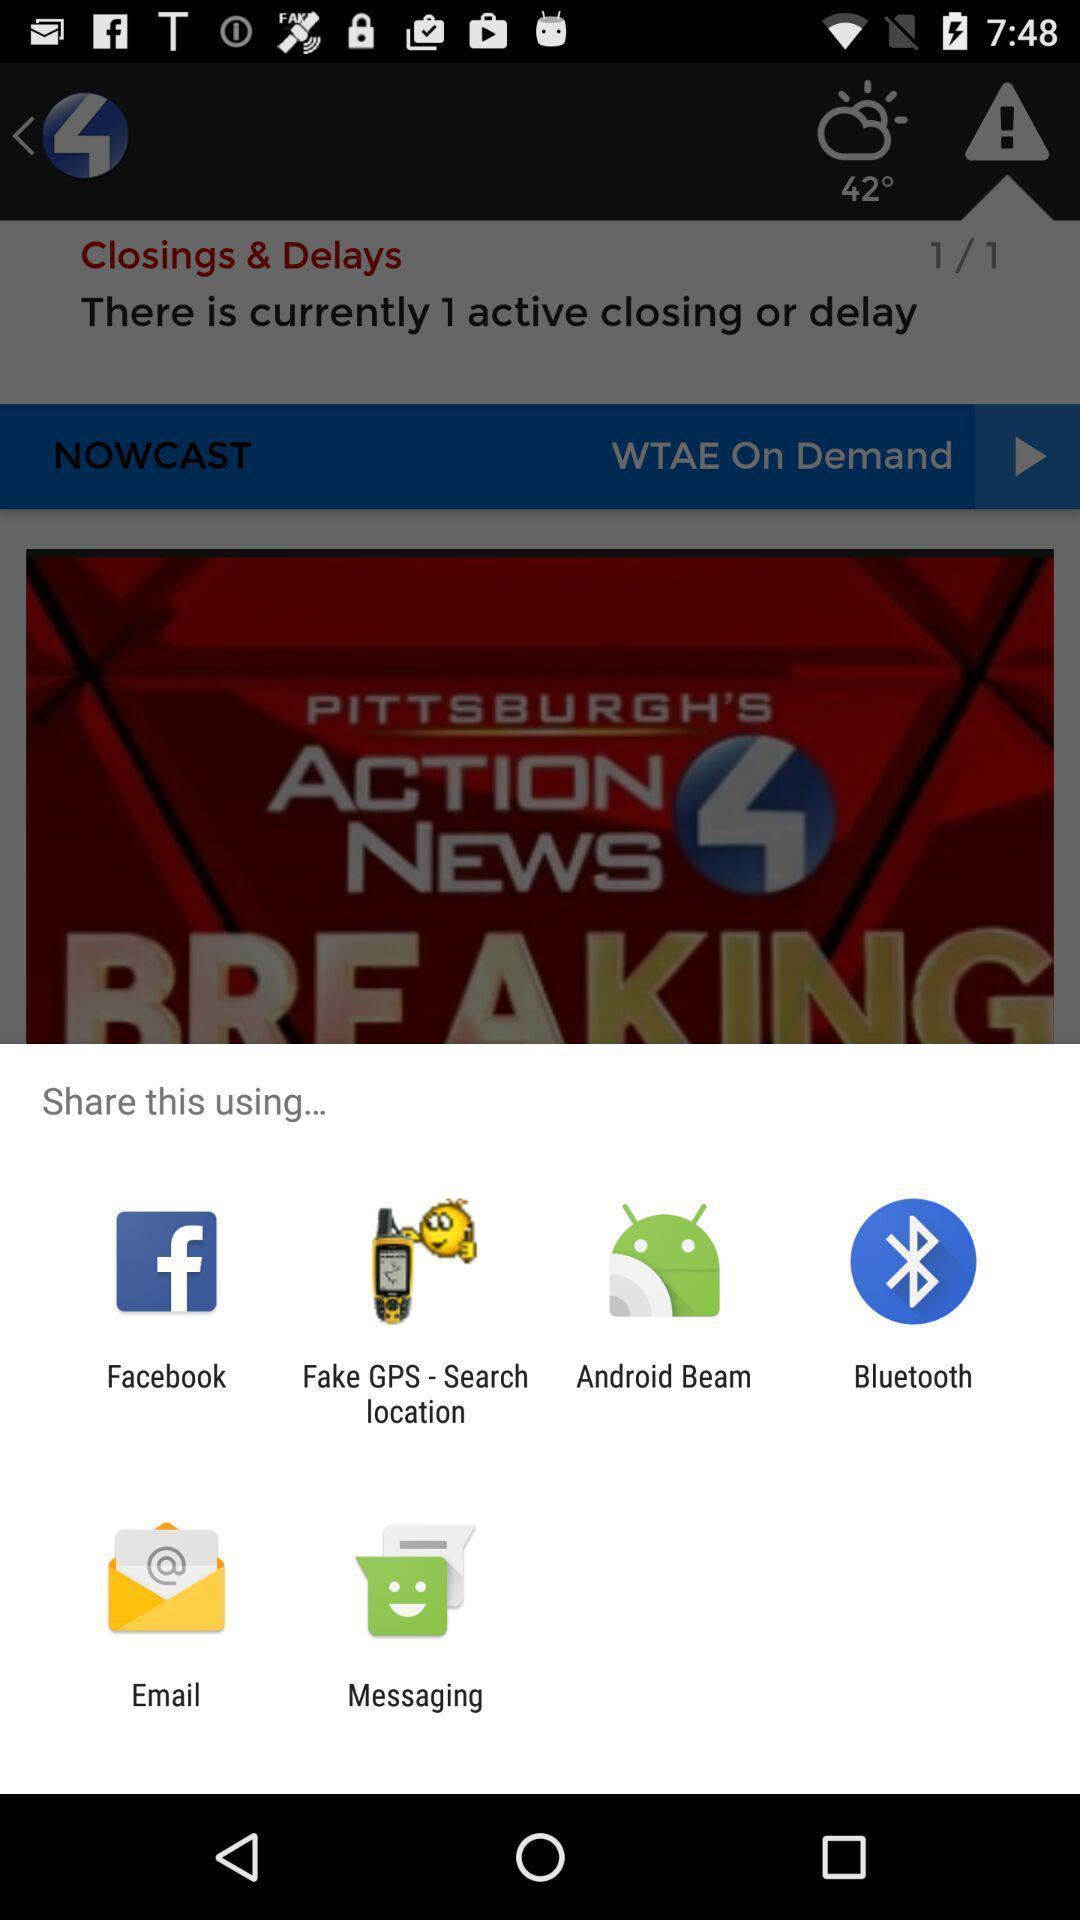Explain what's happening in this screen capture. Pop-up showing various share options. 